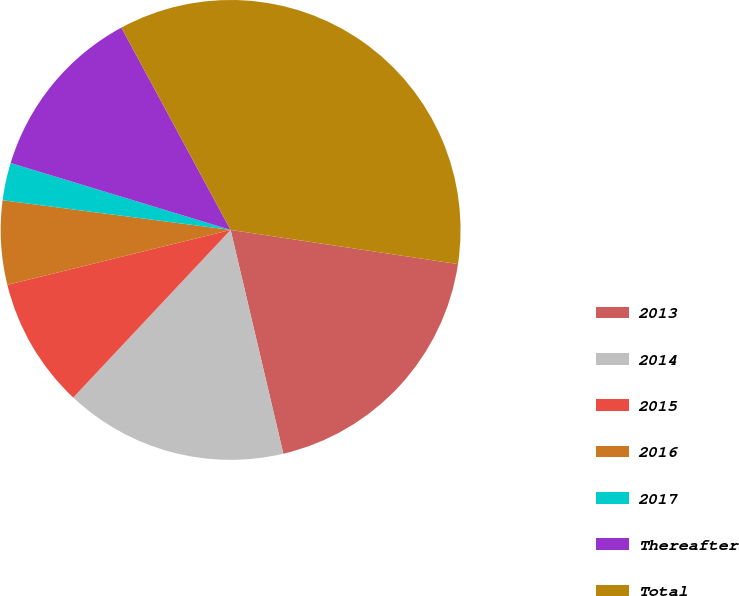Convert chart. <chart><loc_0><loc_0><loc_500><loc_500><pie_chart><fcel>2013<fcel>2014<fcel>2015<fcel>2016<fcel>2017<fcel>Thereafter<fcel>Total<nl><fcel>18.94%<fcel>15.68%<fcel>9.16%<fcel>5.9%<fcel>2.64%<fcel>12.42%<fcel>35.25%<nl></chart> 